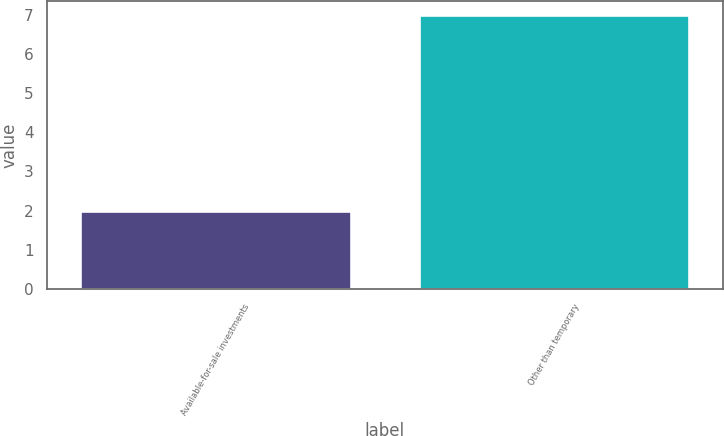Convert chart. <chart><loc_0><loc_0><loc_500><loc_500><bar_chart><fcel>Available-for-sale investments<fcel>Other than temporary<nl><fcel>2<fcel>7<nl></chart> 